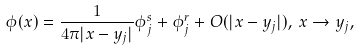<formula> <loc_0><loc_0><loc_500><loc_500>\phi ( x ) = \frac { 1 } { 4 \pi | x - y _ { j } | } \phi _ { j } ^ { s } + \phi _ { j } ^ { r } + O ( | x - y _ { j } | ) , \, x \rightarrow y _ { j } ,</formula> 